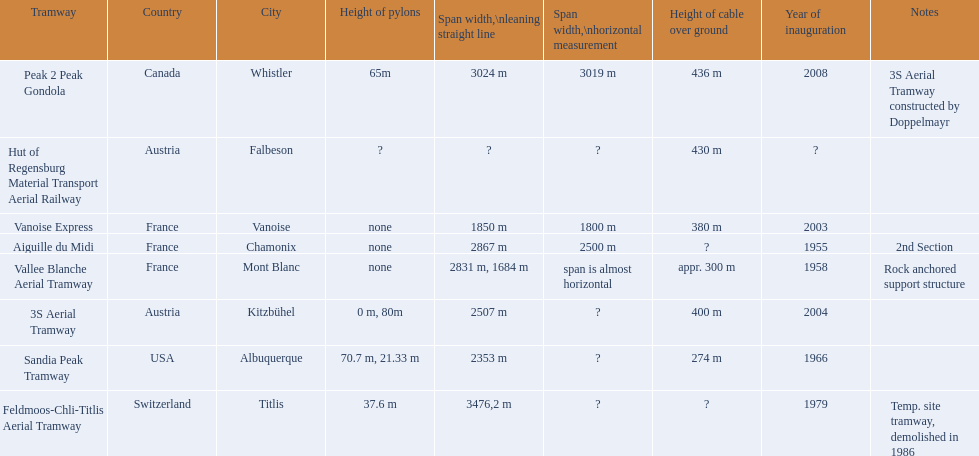In france, which tram systems exist? Vanoise Express, Aiguille du Midi, Vallee Blanche Aerial Tramway. From those, which were introduced in the 1950s? Aiguille du Midi, Vallee Blanche Aerial Tramway. Do any of these tramways feature spans that aren't almost horizontal? Aiguille du Midi. 